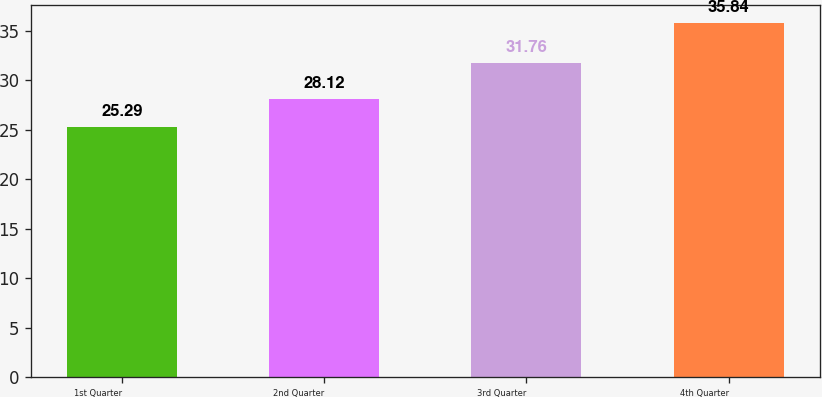Convert chart. <chart><loc_0><loc_0><loc_500><loc_500><bar_chart><fcel>1st Quarter<fcel>2nd Quarter<fcel>3rd Quarter<fcel>4th Quarter<nl><fcel>25.29<fcel>28.12<fcel>31.76<fcel>35.84<nl></chart> 